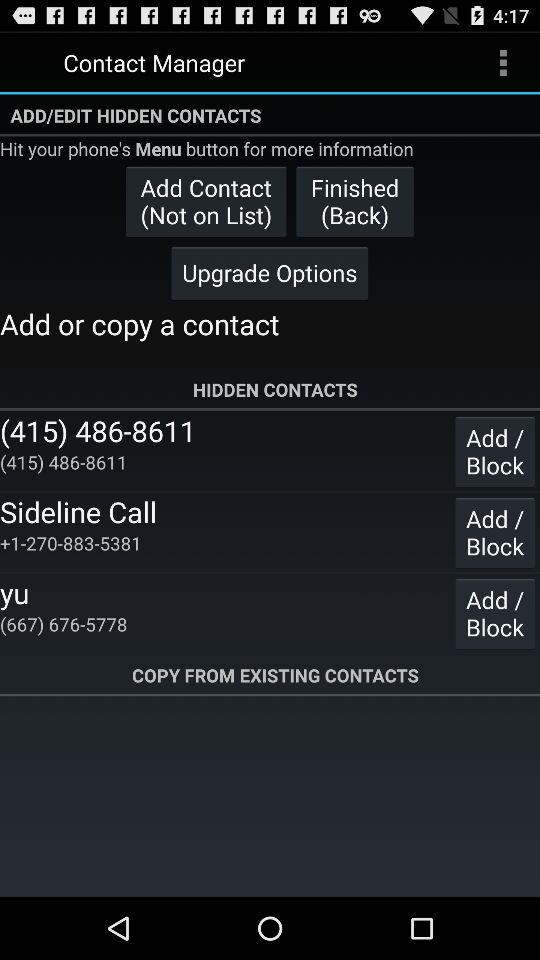What is the phone number for "Sideline Call"? The phone number for "Sideline Call" is +1-270-883-5381. 